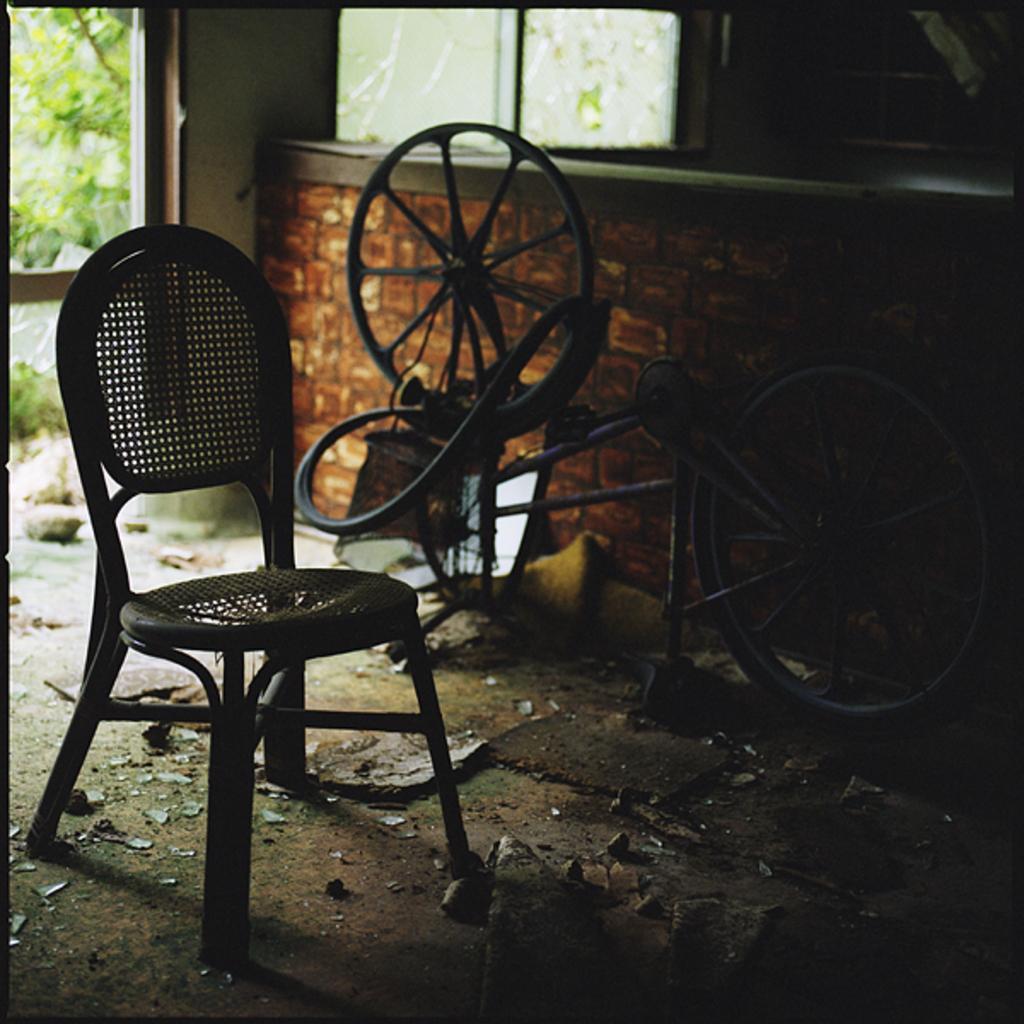How would you summarize this image in a sentence or two? In this Image I see a chair and a cycle on the ground. 